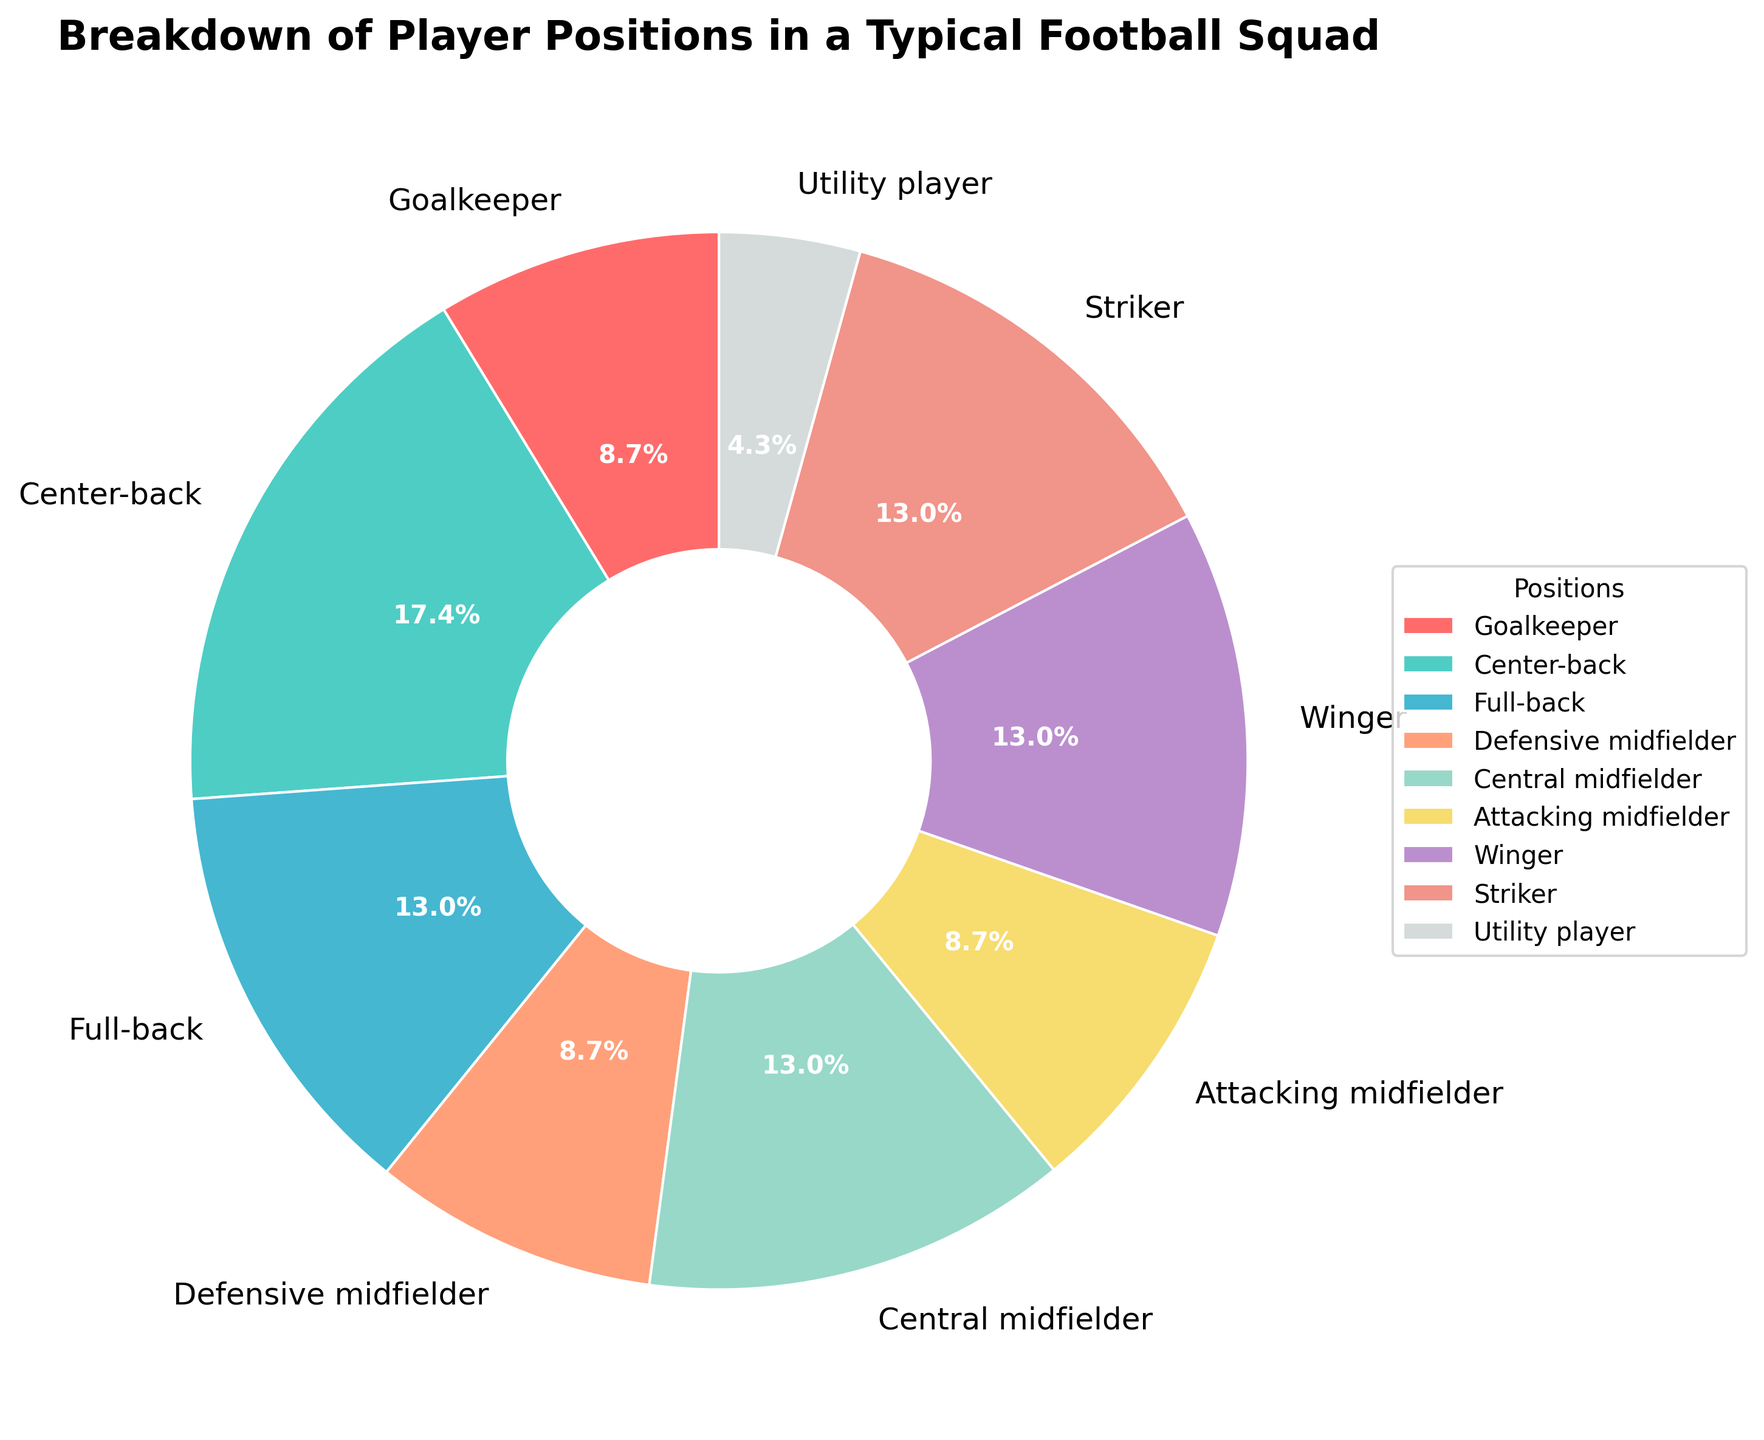Which player position has the highest percentage in the squad? Look at the segment with the largest proportion in the pie chart, which is labeled accordingly.
Answer: Center-back What is the combined percentage of Goalkeepers, Defensive midfielders, and Attacking midfielders? Sum the percentages of Goalkeepers (8.7%), Defensive midfielders (8.7%), and Attacking midfielders (8.7%). 8.7 + 8.7 + 8.7 = 26.1%
Answer: 26.1% Are there more full-backs or strikers? Compare the percentages of Full-backs (13.0%) and Strikers (13.0%).
Answer: Equal Which segments have the same percentage values? Identify segments with the same percentages by looking at their labels in the chart.
Answer: Full-back, Central midfielder, Winger, Striker (all 13.0%) What percentage of the squad is made up of Wingers and Strikers combined? Sum the percentages of Wingers (13.0%) and Strikers (13.0%). 13.0 + 13.0 = 26.0%
Answer: 26.0% Is the percentage of Utility players greater than that of Goalkeepers? Compare the percentages of Utility players (4.3%) and Goalkeepers (8.7%).
Answer: No Which position occupies the smallest segment visually? Identify the smallest segment in the pie chart, labeled accordingly.
Answer: Utility player What is the difference in percentage between Center-back and Utility player? Subtract the percentage of Utility player (4.3%) from the percentage of Center-back (17.4%). 17.4 - 4.3 = 13.1%
Answer: 13.1% What is the percentage of the squad composed of positions other than Goalkeeper, Center-back, and Full-back combined? Sum the percentages of all positions except Goalkeeper (8.7%), Center-back (17.4%), and Full-back (13.0%). 8.7 + 17.4 + 13.0 = 39.1%, 100% - 39.1% = 60.9%
Answer: 60.9% 